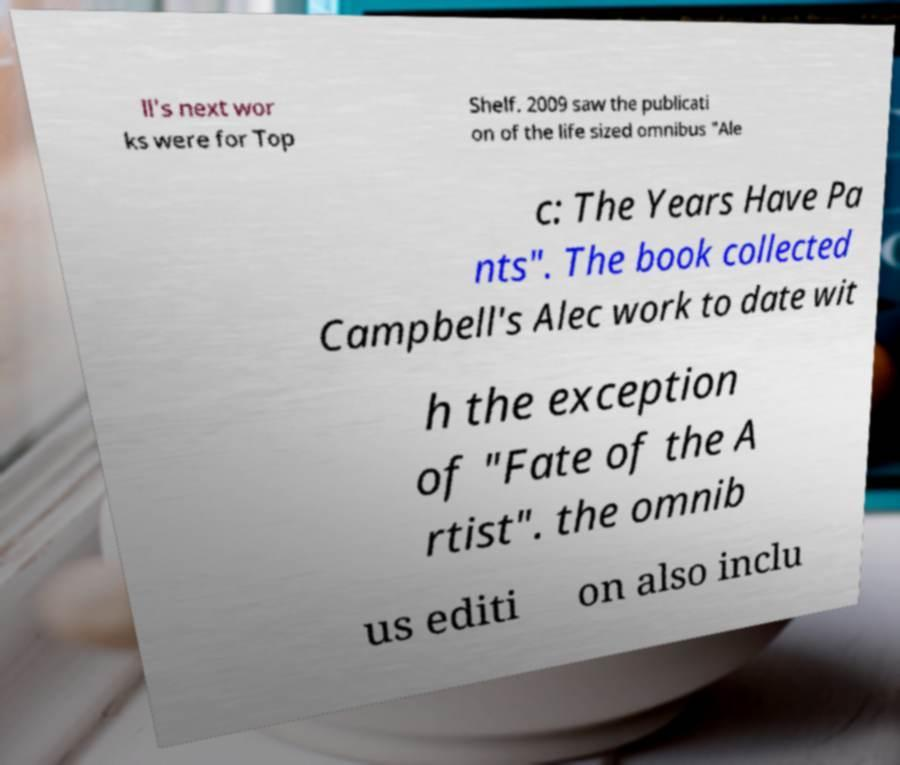For documentation purposes, I need the text within this image transcribed. Could you provide that? ll's next wor ks were for Top Shelf. 2009 saw the publicati on of the life sized omnibus "Ale c: The Years Have Pa nts". The book collected Campbell's Alec work to date wit h the exception of "Fate of the A rtist". the omnib us editi on also inclu 